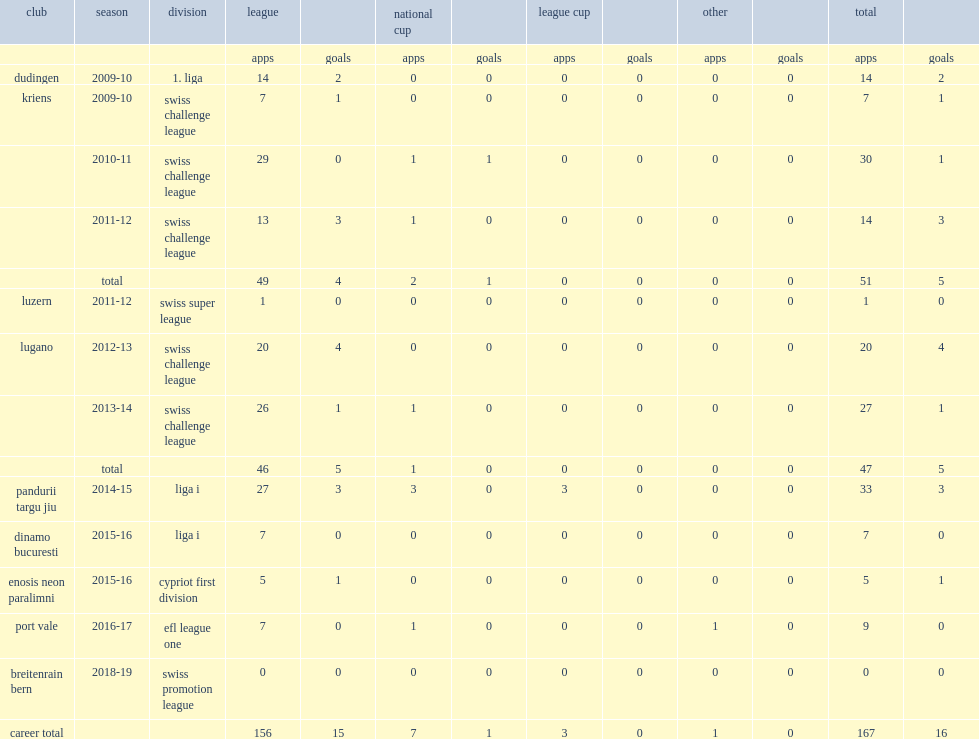Which club did gezim shalaj move on to swiss challenge league for the 2009-10 season? Kriens. 